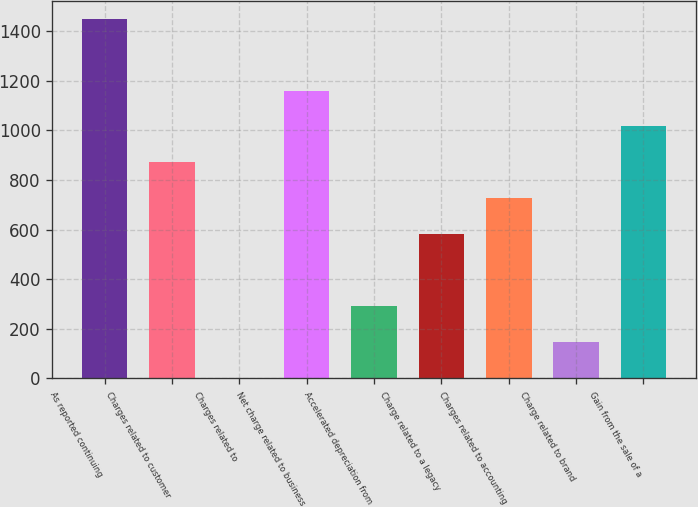<chart> <loc_0><loc_0><loc_500><loc_500><bar_chart><fcel>As reported continuing<fcel>Charges related to customer<fcel>Charges related to<fcel>Net charge related to business<fcel>Accelerated depreciation from<fcel>Charge related to a legacy<fcel>Charges related to accounting<fcel>Charge related to brand<fcel>Gain from the sale of a<nl><fcel>1449<fcel>871<fcel>4<fcel>1160<fcel>293<fcel>582<fcel>726.5<fcel>148.5<fcel>1015.5<nl></chart> 